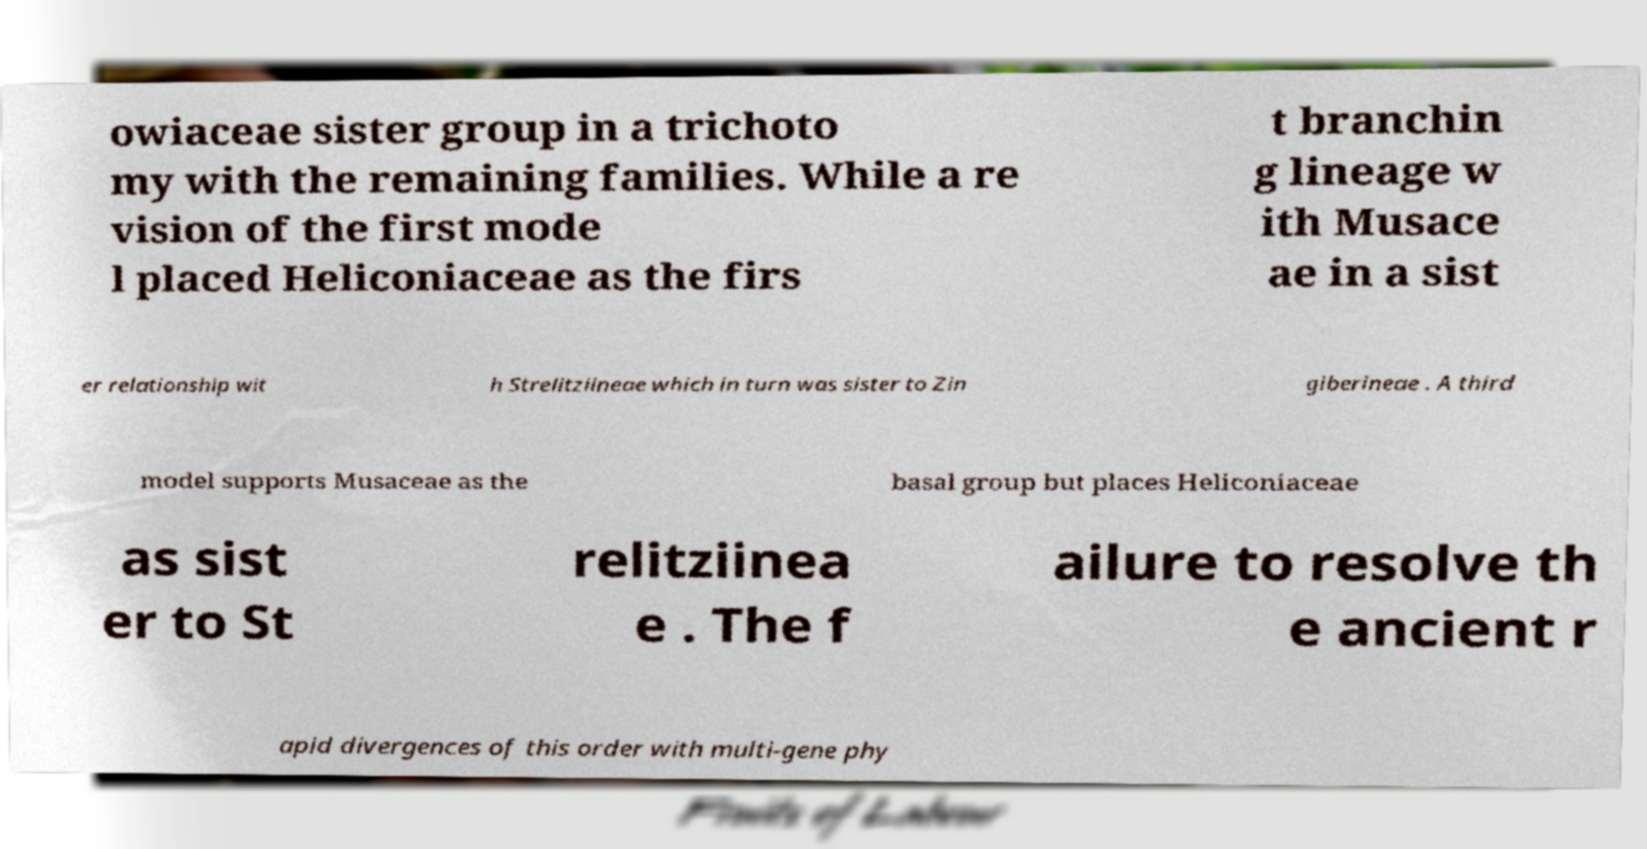I need the written content from this picture converted into text. Can you do that? owiaceae sister group in a trichoto my with the remaining families. While a re vision of the first mode l placed Heliconiaceae as the firs t branchin g lineage w ith Musace ae in a sist er relationship wit h Strelitziineae which in turn was sister to Zin giberineae . A third model supports Musaceae as the basal group but places Heliconiaceae as sist er to St relitziinea e . The f ailure to resolve th e ancient r apid divergences of this order with multi-gene phy 